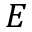Convert formula to latex. <formula><loc_0><loc_0><loc_500><loc_500>E</formula> 